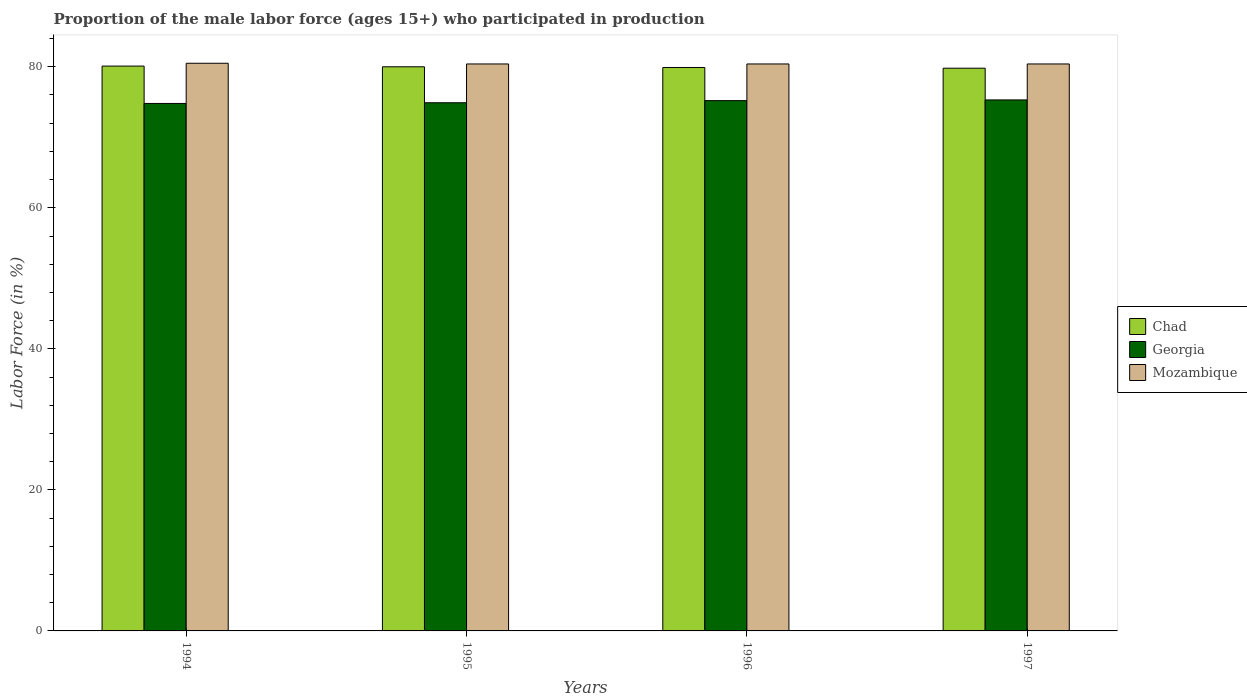How many groups of bars are there?
Your answer should be very brief. 4. How many bars are there on the 3rd tick from the right?
Your answer should be compact. 3. What is the label of the 4th group of bars from the left?
Keep it short and to the point. 1997. In how many cases, is the number of bars for a given year not equal to the number of legend labels?
Your answer should be very brief. 0. What is the proportion of the male labor force who participated in production in Mozambique in 1997?
Your answer should be compact. 80.4. Across all years, what is the maximum proportion of the male labor force who participated in production in Georgia?
Your answer should be compact. 75.3. Across all years, what is the minimum proportion of the male labor force who participated in production in Mozambique?
Make the answer very short. 80.4. In which year was the proportion of the male labor force who participated in production in Chad maximum?
Keep it short and to the point. 1994. In which year was the proportion of the male labor force who participated in production in Georgia minimum?
Make the answer very short. 1994. What is the total proportion of the male labor force who participated in production in Mozambique in the graph?
Give a very brief answer. 321.7. What is the difference between the proportion of the male labor force who participated in production in Georgia in 1996 and that in 1997?
Provide a succinct answer. -0.1. What is the difference between the proportion of the male labor force who participated in production in Mozambique in 1996 and the proportion of the male labor force who participated in production in Chad in 1995?
Keep it short and to the point. 0.4. What is the average proportion of the male labor force who participated in production in Chad per year?
Your response must be concise. 79.95. In the year 1995, what is the difference between the proportion of the male labor force who participated in production in Chad and proportion of the male labor force who participated in production in Georgia?
Ensure brevity in your answer.  5.1. What is the ratio of the proportion of the male labor force who participated in production in Chad in 1996 to that in 1997?
Ensure brevity in your answer.  1. Is the proportion of the male labor force who participated in production in Georgia in 1996 less than that in 1997?
Keep it short and to the point. Yes. Is the difference between the proportion of the male labor force who participated in production in Chad in 1994 and 1997 greater than the difference between the proportion of the male labor force who participated in production in Georgia in 1994 and 1997?
Offer a terse response. Yes. What is the difference between the highest and the second highest proportion of the male labor force who participated in production in Mozambique?
Your answer should be compact. 0.1. What is the difference between the highest and the lowest proportion of the male labor force who participated in production in Chad?
Ensure brevity in your answer.  0.3. What does the 2nd bar from the left in 1995 represents?
Offer a terse response. Georgia. What does the 3rd bar from the right in 1994 represents?
Your answer should be very brief. Chad. Is it the case that in every year, the sum of the proportion of the male labor force who participated in production in Mozambique and proportion of the male labor force who participated in production in Georgia is greater than the proportion of the male labor force who participated in production in Chad?
Provide a succinct answer. Yes. How many bars are there?
Keep it short and to the point. 12. Are all the bars in the graph horizontal?
Offer a terse response. No. Are the values on the major ticks of Y-axis written in scientific E-notation?
Ensure brevity in your answer.  No. Does the graph contain grids?
Give a very brief answer. No. How many legend labels are there?
Provide a succinct answer. 3. What is the title of the graph?
Make the answer very short. Proportion of the male labor force (ages 15+) who participated in production. What is the Labor Force (in %) in Chad in 1994?
Your answer should be compact. 80.1. What is the Labor Force (in %) in Georgia in 1994?
Give a very brief answer. 74.8. What is the Labor Force (in %) of Mozambique in 1994?
Your answer should be compact. 80.5. What is the Labor Force (in %) in Georgia in 1995?
Your answer should be very brief. 74.9. What is the Labor Force (in %) of Mozambique in 1995?
Your answer should be very brief. 80.4. What is the Labor Force (in %) of Chad in 1996?
Keep it short and to the point. 79.9. What is the Labor Force (in %) in Georgia in 1996?
Offer a terse response. 75.2. What is the Labor Force (in %) in Mozambique in 1996?
Your answer should be compact. 80.4. What is the Labor Force (in %) of Chad in 1997?
Make the answer very short. 79.8. What is the Labor Force (in %) in Georgia in 1997?
Ensure brevity in your answer.  75.3. What is the Labor Force (in %) of Mozambique in 1997?
Keep it short and to the point. 80.4. Across all years, what is the maximum Labor Force (in %) in Chad?
Offer a terse response. 80.1. Across all years, what is the maximum Labor Force (in %) of Georgia?
Provide a short and direct response. 75.3. Across all years, what is the maximum Labor Force (in %) of Mozambique?
Your answer should be very brief. 80.5. Across all years, what is the minimum Labor Force (in %) of Chad?
Give a very brief answer. 79.8. Across all years, what is the minimum Labor Force (in %) of Georgia?
Provide a succinct answer. 74.8. Across all years, what is the minimum Labor Force (in %) of Mozambique?
Keep it short and to the point. 80.4. What is the total Labor Force (in %) in Chad in the graph?
Your answer should be very brief. 319.8. What is the total Labor Force (in %) of Georgia in the graph?
Offer a very short reply. 300.2. What is the total Labor Force (in %) in Mozambique in the graph?
Your answer should be very brief. 321.7. What is the difference between the Labor Force (in %) of Georgia in 1994 and that in 1995?
Provide a short and direct response. -0.1. What is the difference between the Labor Force (in %) in Mozambique in 1994 and that in 1995?
Keep it short and to the point. 0.1. What is the difference between the Labor Force (in %) of Chad in 1994 and that in 1997?
Make the answer very short. 0.3. What is the difference between the Labor Force (in %) in Georgia in 1995 and that in 1996?
Offer a terse response. -0.3. What is the difference between the Labor Force (in %) in Mozambique in 1995 and that in 1996?
Offer a terse response. 0. What is the difference between the Labor Force (in %) in Chad in 1995 and that in 1997?
Your response must be concise. 0.2. What is the difference between the Labor Force (in %) in Georgia in 1996 and that in 1997?
Offer a terse response. -0.1. What is the difference between the Labor Force (in %) of Mozambique in 1996 and that in 1997?
Your answer should be very brief. 0. What is the difference between the Labor Force (in %) in Chad in 1994 and the Labor Force (in %) in Georgia in 1995?
Provide a short and direct response. 5.2. What is the difference between the Labor Force (in %) in Georgia in 1994 and the Labor Force (in %) in Mozambique in 1995?
Ensure brevity in your answer.  -5.6. What is the difference between the Labor Force (in %) in Georgia in 1994 and the Labor Force (in %) in Mozambique in 1997?
Your answer should be compact. -5.6. What is the difference between the Labor Force (in %) of Georgia in 1996 and the Labor Force (in %) of Mozambique in 1997?
Keep it short and to the point. -5.2. What is the average Labor Force (in %) of Chad per year?
Your answer should be compact. 79.95. What is the average Labor Force (in %) in Georgia per year?
Provide a short and direct response. 75.05. What is the average Labor Force (in %) in Mozambique per year?
Your answer should be very brief. 80.42. In the year 1994, what is the difference between the Labor Force (in %) of Chad and Labor Force (in %) of Georgia?
Offer a very short reply. 5.3. In the year 1995, what is the difference between the Labor Force (in %) of Georgia and Labor Force (in %) of Mozambique?
Your answer should be compact. -5.5. In the year 1997, what is the difference between the Labor Force (in %) of Chad and Labor Force (in %) of Georgia?
Your response must be concise. 4.5. In the year 1997, what is the difference between the Labor Force (in %) in Chad and Labor Force (in %) in Mozambique?
Offer a terse response. -0.6. What is the ratio of the Labor Force (in %) in Georgia in 1994 to that in 1995?
Keep it short and to the point. 1. What is the ratio of the Labor Force (in %) in Mozambique in 1994 to that in 1995?
Offer a very short reply. 1. What is the ratio of the Labor Force (in %) in Chad in 1994 to that in 1996?
Keep it short and to the point. 1. What is the ratio of the Labor Force (in %) in Georgia in 1994 to that in 1996?
Your answer should be compact. 0.99. What is the ratio of the Labor Force (in %) of Mozambique in 1994 to that in 1996?
Offer a terse response. 1. What is the ratio of the Labor Force (in %) in Chad in 1994 to that in 1997?
Ensure brevity in your answer.  1. What is the ratio of the Labor Force (in %) of Mozambique in 1994 to that in 1997?
Your answer should be compact. 1. What is the ratio of the Labor Force (in %) of Georgia in 1995 to that in 1996?
Keep it short and to the point. 1. What is the ratio of the Labor Force (in %) of Chad in 1996 to that in 1997?
Provide a short and direct response. 1. What is the ratio of the Labor Force (in %) of Mozambique in 1996 to that in 1997?
Your answer should be compact. 1. What is the difference between the highest and the second highest Labor Force (in %) of Georgia?
Keep it short and to the point. 0.1. What is the difference between the highest and the second highest Labor Force (in %) of Mozambique?
Offer a terse response. 0.1. 